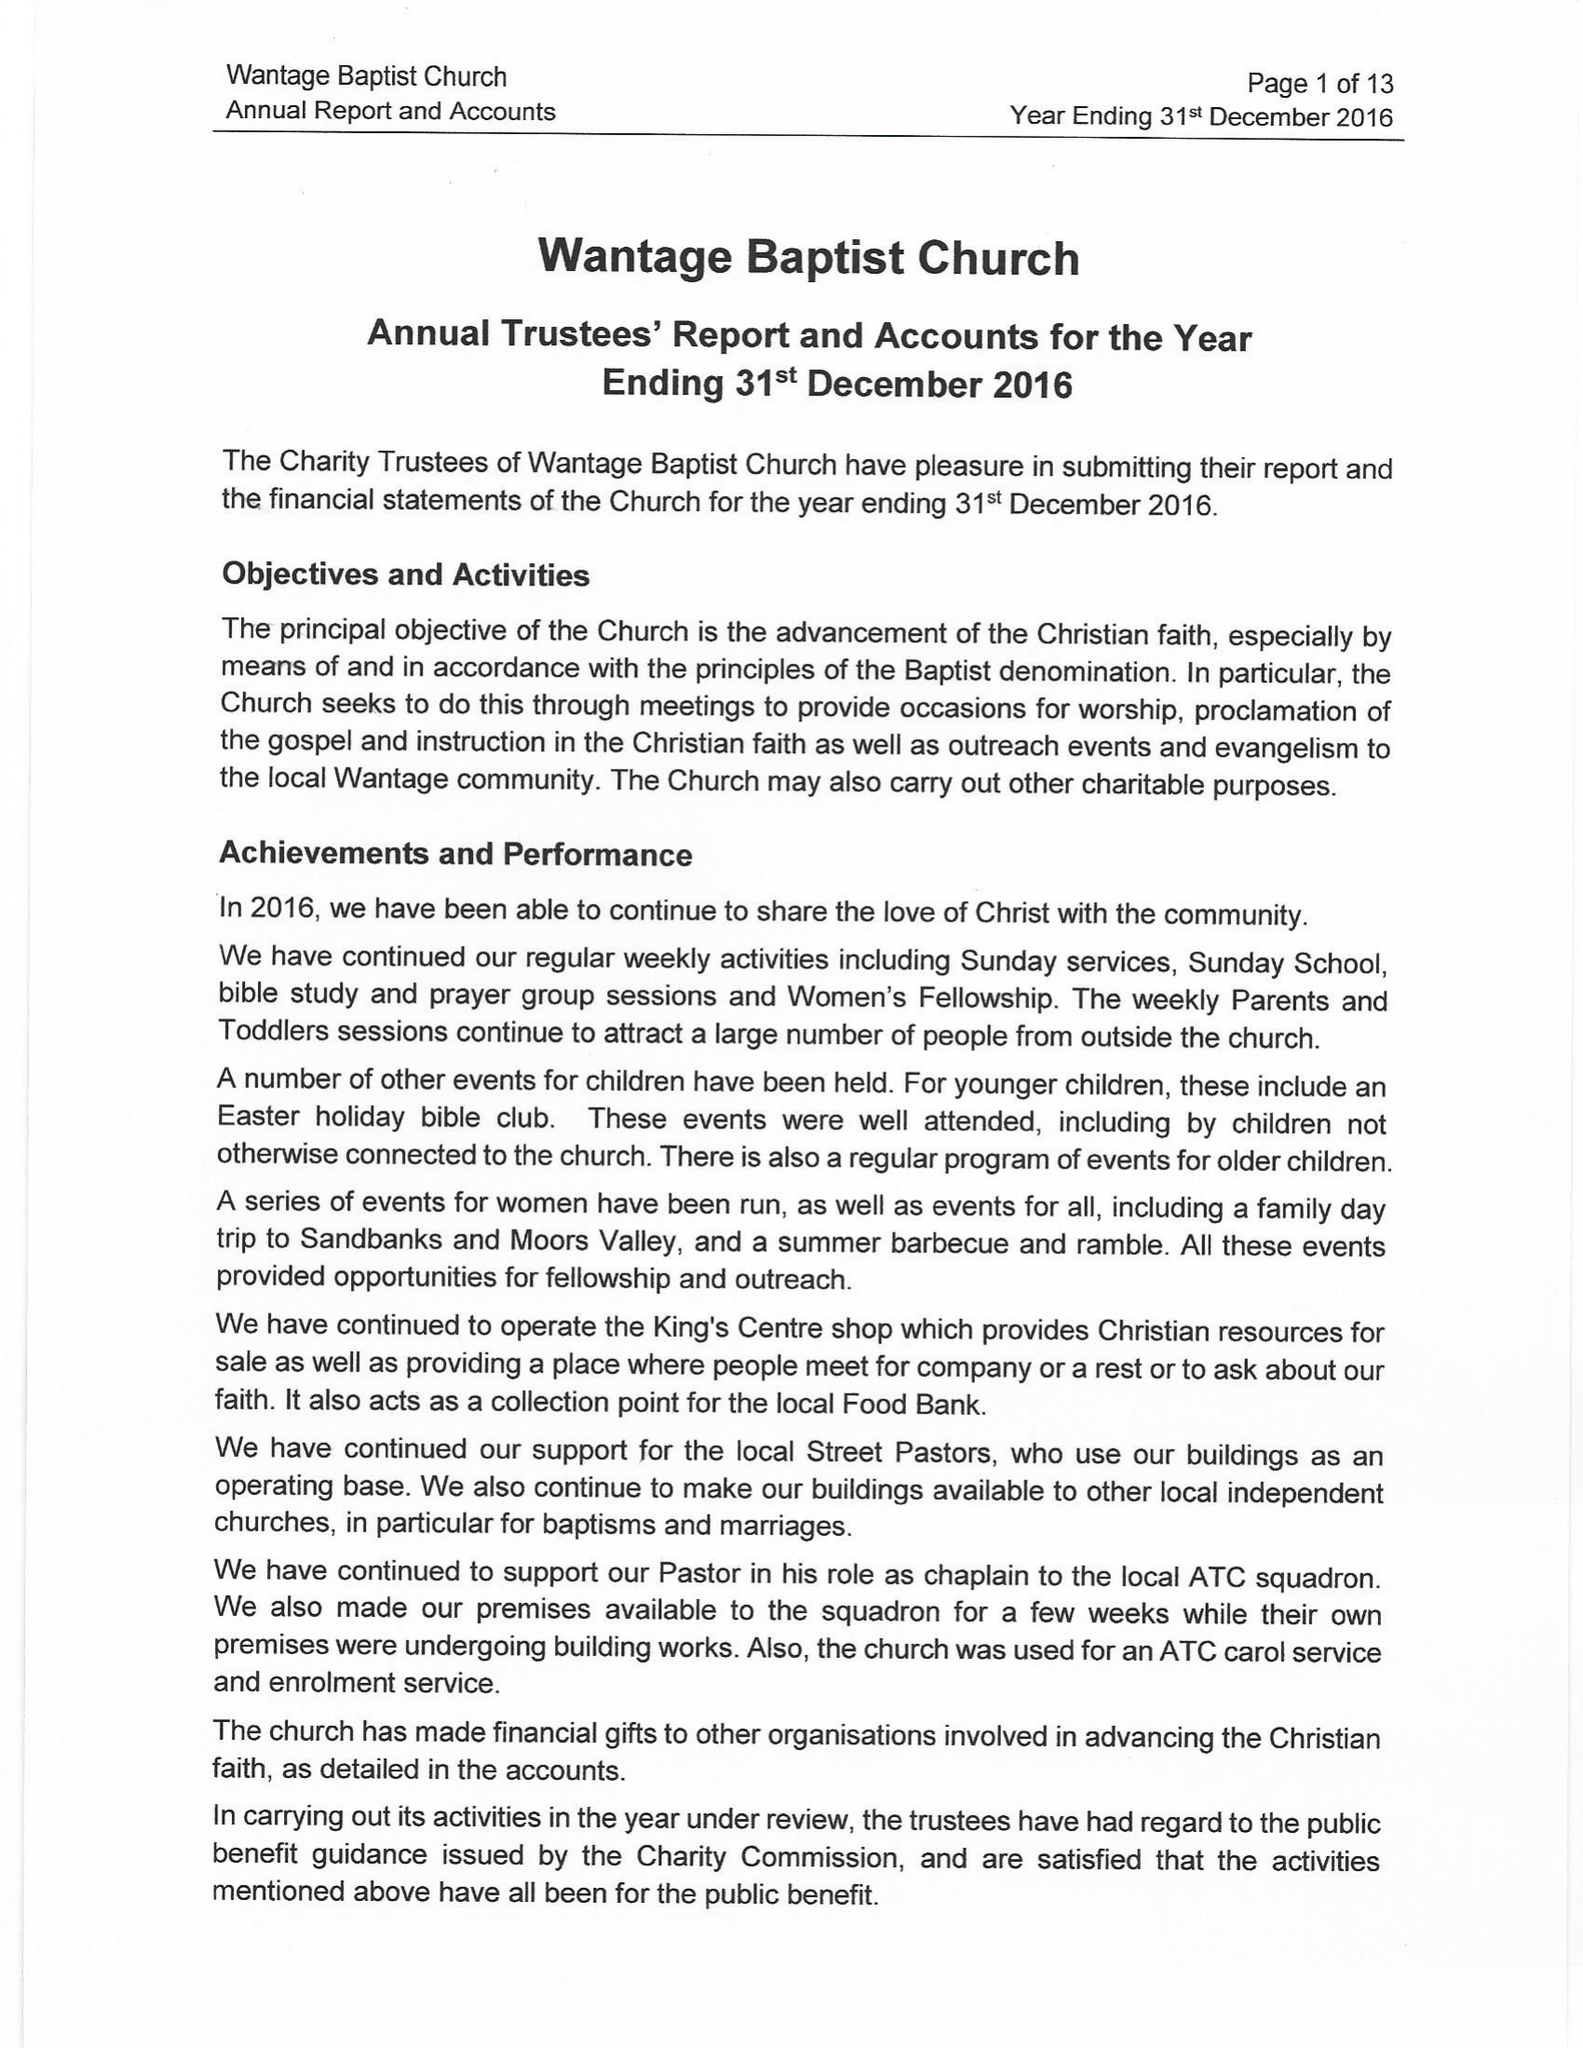What is the value for the charity_number?
Answer the question using a single word or phrase. 1163191 